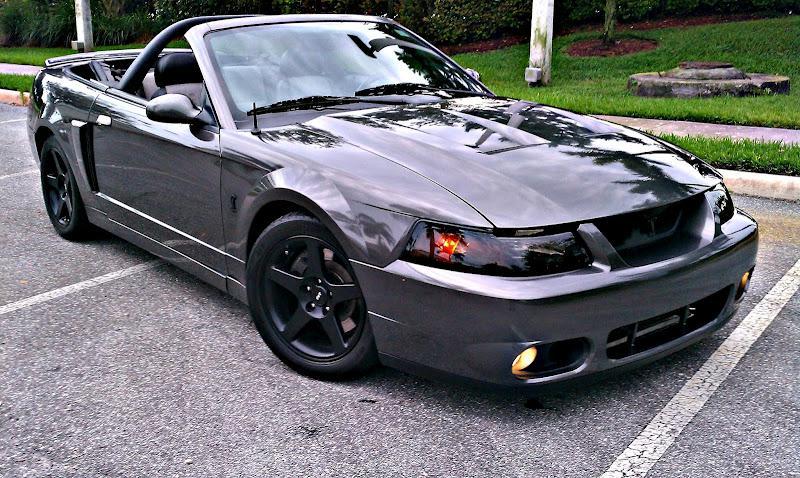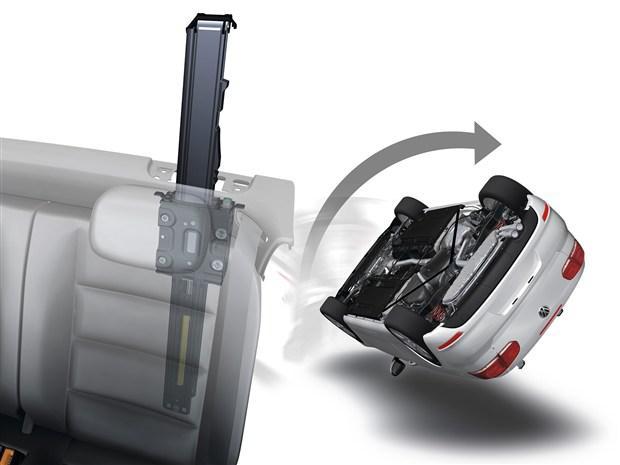The first image is the image on the left, the second image is the image on the right. For the images shown, is this caption "A white car is parked on the road in one of the images." true? Answer yes or no. No. The first image is the image on the left, the second image is the image on the right. Examine the images to the left and right. Is the description "An image shows a white topless convertible displayed parked at an angle on pavement." accurate? Answer yes or no. No. 